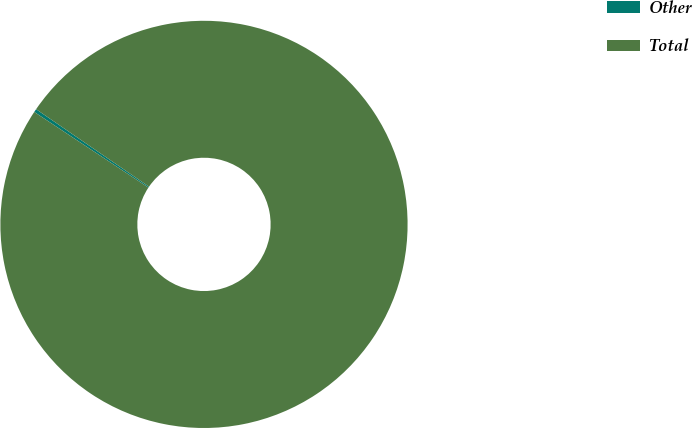<chart> <loc_0><loc_0><loc_500><loc_500><pie_chart><fcel>Other<fcel>Total<nl><fcel>0.26%<fcel>99.74%<nl></chart> 